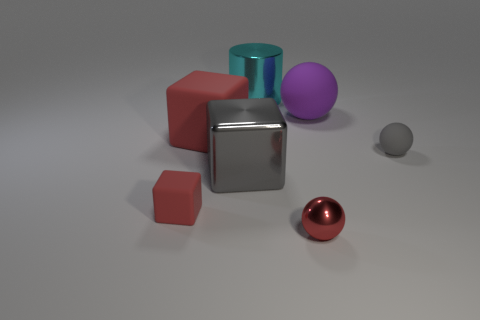Is the number of cyan metal cylinders left of the cyan shiny cylinder greater than the number of purple rubber spheres that are in front of the purple matte sphere?
Provide a short and direct response. No. What is the size of the purple rubber ball?
Keep it short and to the point. Large. The small red object that is on the right side of the metallic cylinder has what shape?
Keep it short and to the point. Sphere. Does the large cyan thing have the same shape as the tiny red matte object?
Your response must be concise. No. Is the number of large purple matte balls to the left of the purple rubber thing the same as the number of large yellow spheres?
Ensure brevity in your answer.  Yes. The big purple rubber thing has what shape?
Your answer should be very brief. Sphere. Is there anything else of the same color as the big shiny cylinder?
Provide a succinct answer. No. Is the size of the gray thing that is to the right of the big rubber sphere the same as the ball in front of the small red matte cube?
Ensure brevity in your answer.  Yes. What is the shape of the big red thing that is to the left of the tiny ball to the right of the red shiny sphere?
Your response must be concise. Cube. Does the cyan metallic cylinder have the same size as the red rubber thing that is in front of the big shiny block?
Your response must be concise. No. 